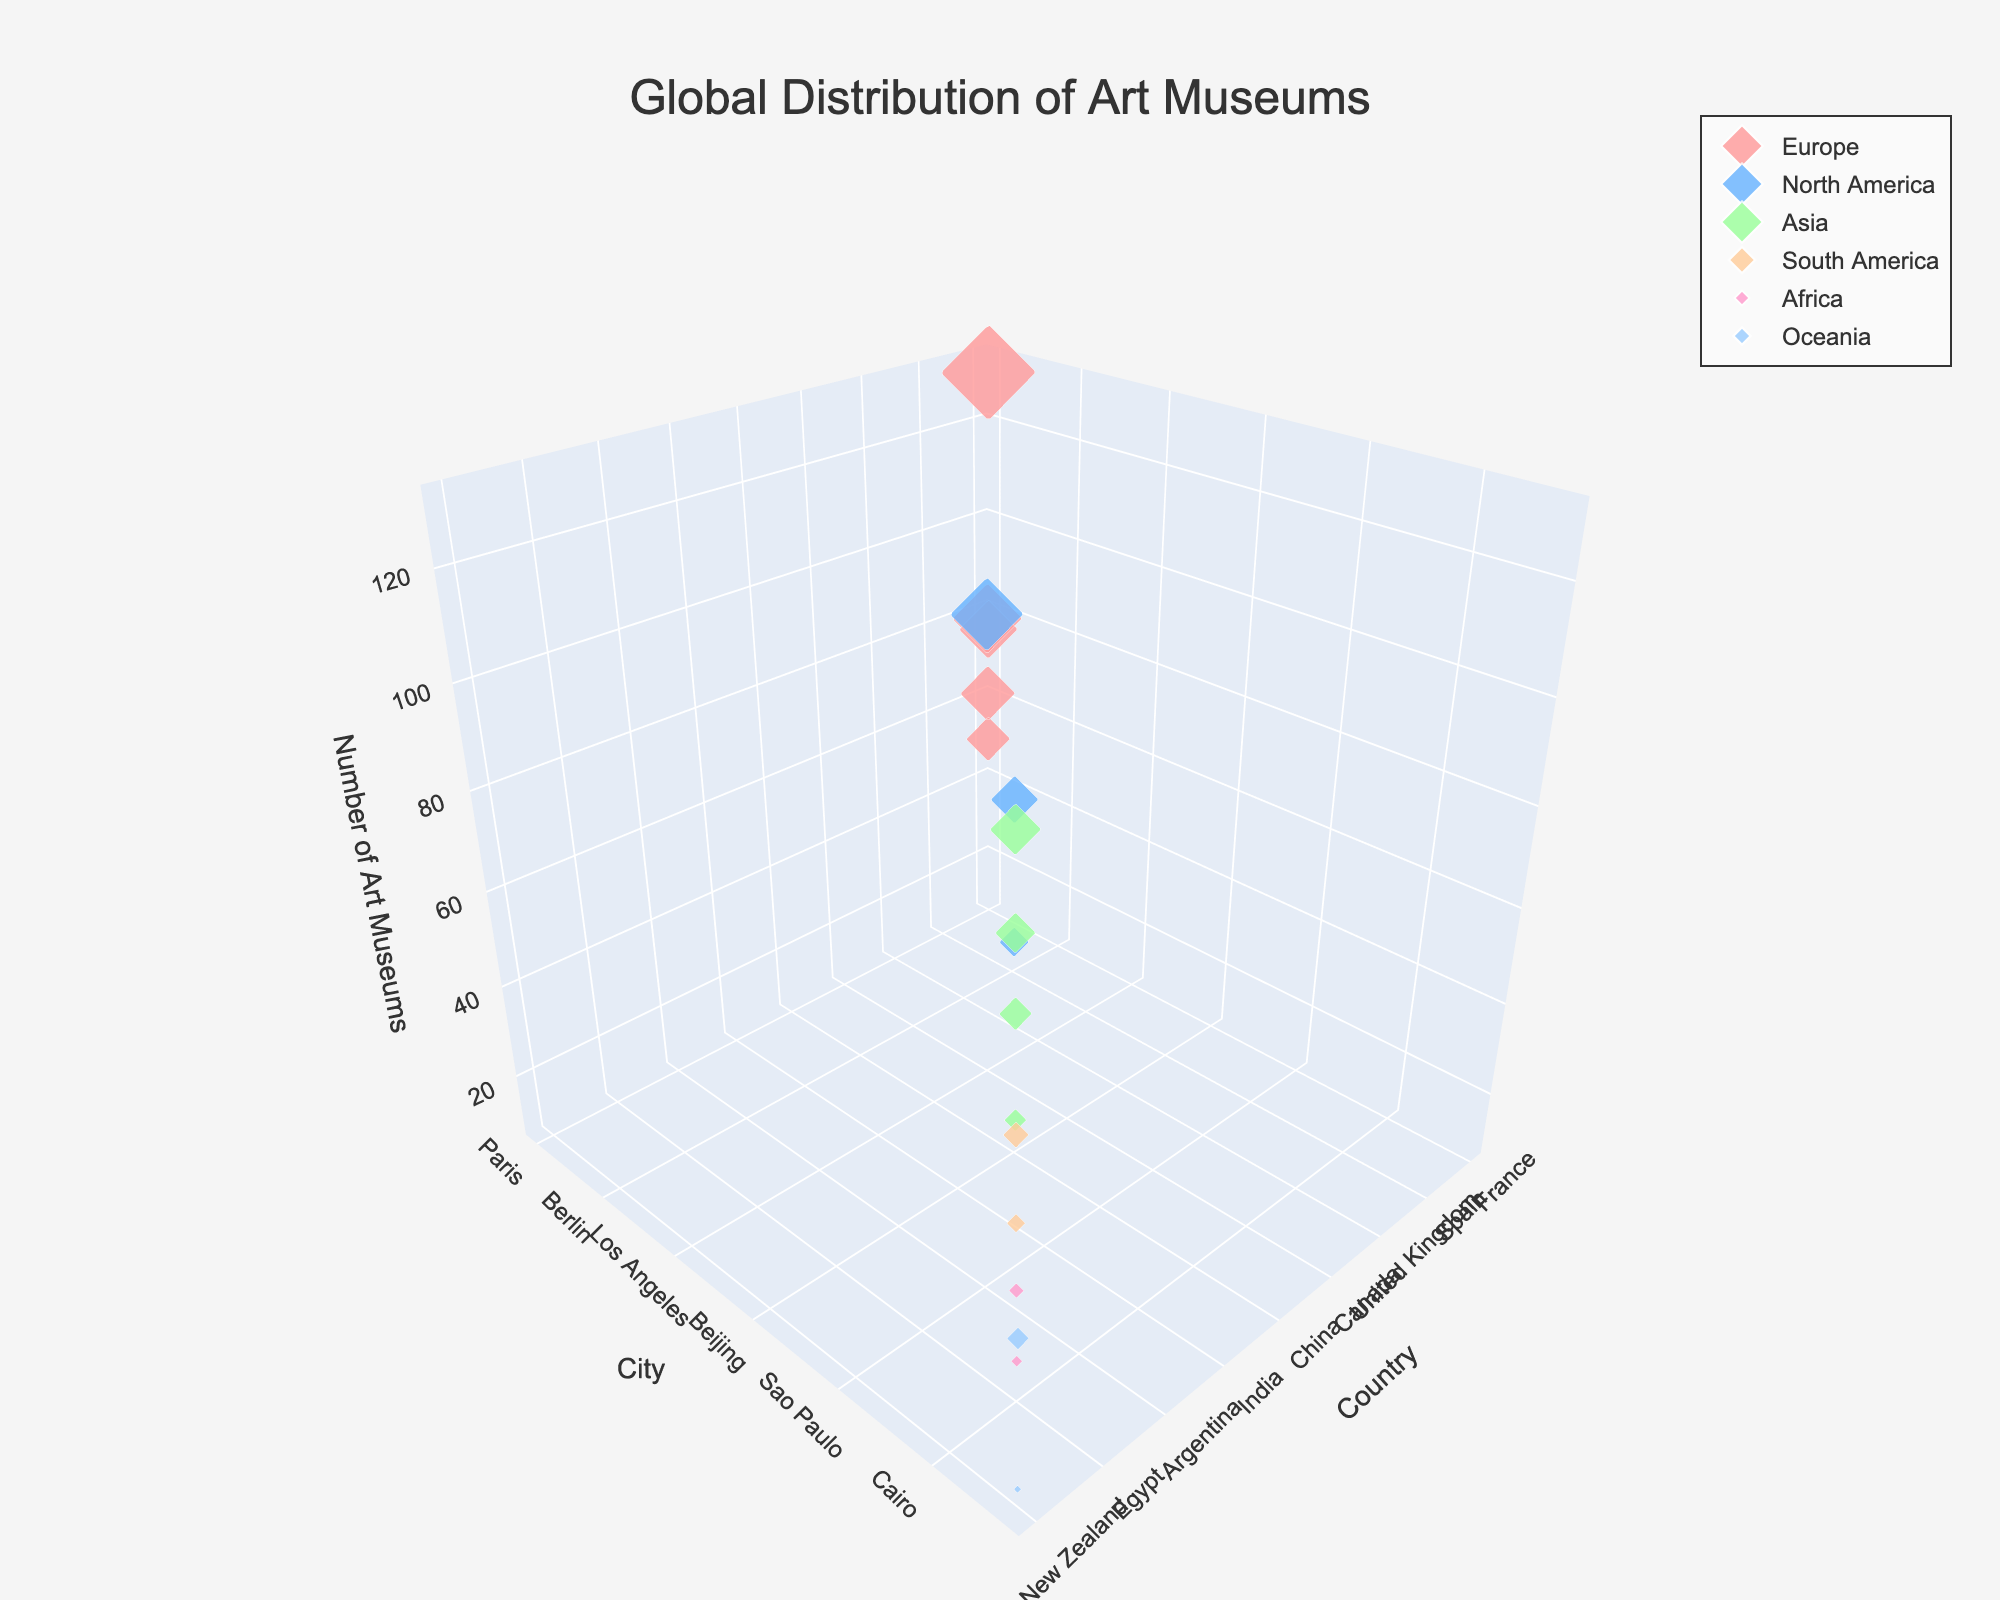How many art museums are there in Paris? Locate Paris under the 'City' label and check the corresponding 'Number of Art Museums'.
Answer: 130 Which continent has the most countries represented in the figure? Count the unique countries for each continent and identify the continent with the highest count. Europe has France, Italy, Spain, Germany, United Kingdom resulting in 5 unique countries.
Answer: Europe Which city in North America has the highest number of art museums? Identify North American cities and compare their 'Number of Art Museums'. New York City has the highest value.
Answer: New York City Is the number of art museums in London greater than in Rome? Compare the 'Number of Art Museums' for London (95) and Rome (80).
Answer: Yes How many art museums are there in total in Asia? Sum the 'Number of Art Museums' for Tokyo, Beijing, Seoul, and Mumbai: 70 + 55 + 45 + 30.
Answer: 200 Which city has the least number of art museums in the figure? Locate the city with the smallest 'Number of Art Museums'. Wellington has the lowest value.
Answer: Wellington How does the number of art museums in Sydney compare to Buenos Aires? Compare the 'Number of Art Museums' for Sydney (30) and Buenos Aires (25).
Answer: Sydney has more What is the average number of art museums in European cities? Sum the 'Number of Art Museums' in European cities (130 + 80 + 60 + 75 + 95 = 440) and divide by the number of cities (5).
Answer: 88 Which continent has the most evenly distributed number of art museums across its cities? Compare the distribution of values for each continent. Europe shows relatively close values: 130, 80, 60, 75, 95.
Answer: Europe 